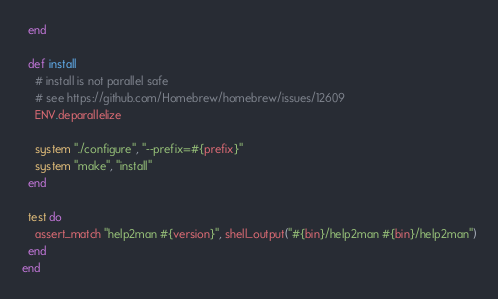<code> <loc_0><loc_0><loc_500><loc_500><_Ruby_>  end

  def install
    # install is not parallel safe
    # see https://github.com/Homebrew/homebrew/issues/12609
    ENV.deparallelize

    system "./configure", "--prefix=#{prefix}"
    system "make", "install"
  end

  test do
    assert_match "help2man #{version}", shell_output("#{bin}/help2man #{bin}/help2man")
  end
end
</code> 